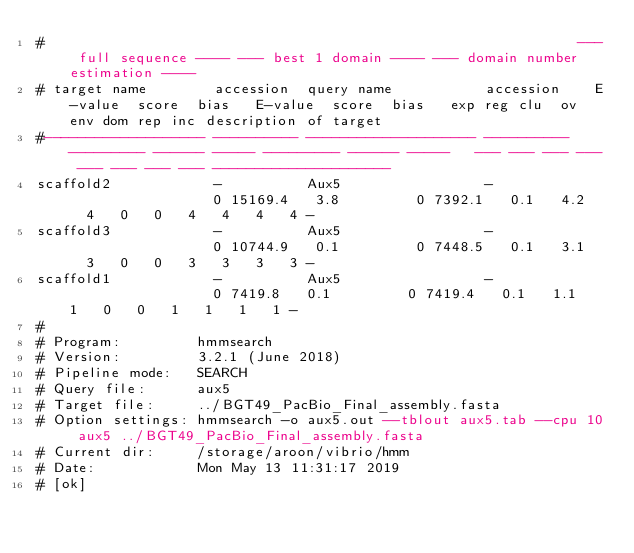Convert code to text. <code><loc_0><loc_0><loc_500><loc_500><_SQL_>#                                                               --- full sequence ---- --- best 1 domain ---- --- domain number estimation ----
# target name        accession  query name           accession    E-value  score  bias   E-value  score  bias   exp reg clu  ov env dom rep inc description of target
#------------------- ---------- -------------------- ---------- --------- ------ ----- --------- ------ -----   --- --- --- --- --- --- --- --- ---------------------
scaffold2            -          Aux5                 -                  0 15169.4   3.8         0 7392.1   0.1   4.2   4   0   0   4   4   4   4 -
scaffold3            -          Aux5                 -                  0 10744.9   0.1         0 7448.5   0.1   3.1   3   0   0   3   3   3   3 -
scaffold1            -          Aux5                 -                  0 7419.8   0.1         0 7419.4   0.1   1.1   1   0   0   1   1   1   1 -
#
# Program:         hmmsearch
# Version:         3.2.1 (June 2018)
# Pipeline mode:   SEARCH
# Query file:      aux5
# Target file:     ../BGT49_PacBio_Final_assembly.fasta
# Option settings: hmmsearch -o aux5.out --tblout aux5.tab --cpu 10 aux5 ../BGT49_PacBio_Final_assembly.fasta 
# Current dir:     /storage/aroon/vibrio/hmm
# Date:            Mon May 13 11:31:17 2019
# [ok]
</code> 